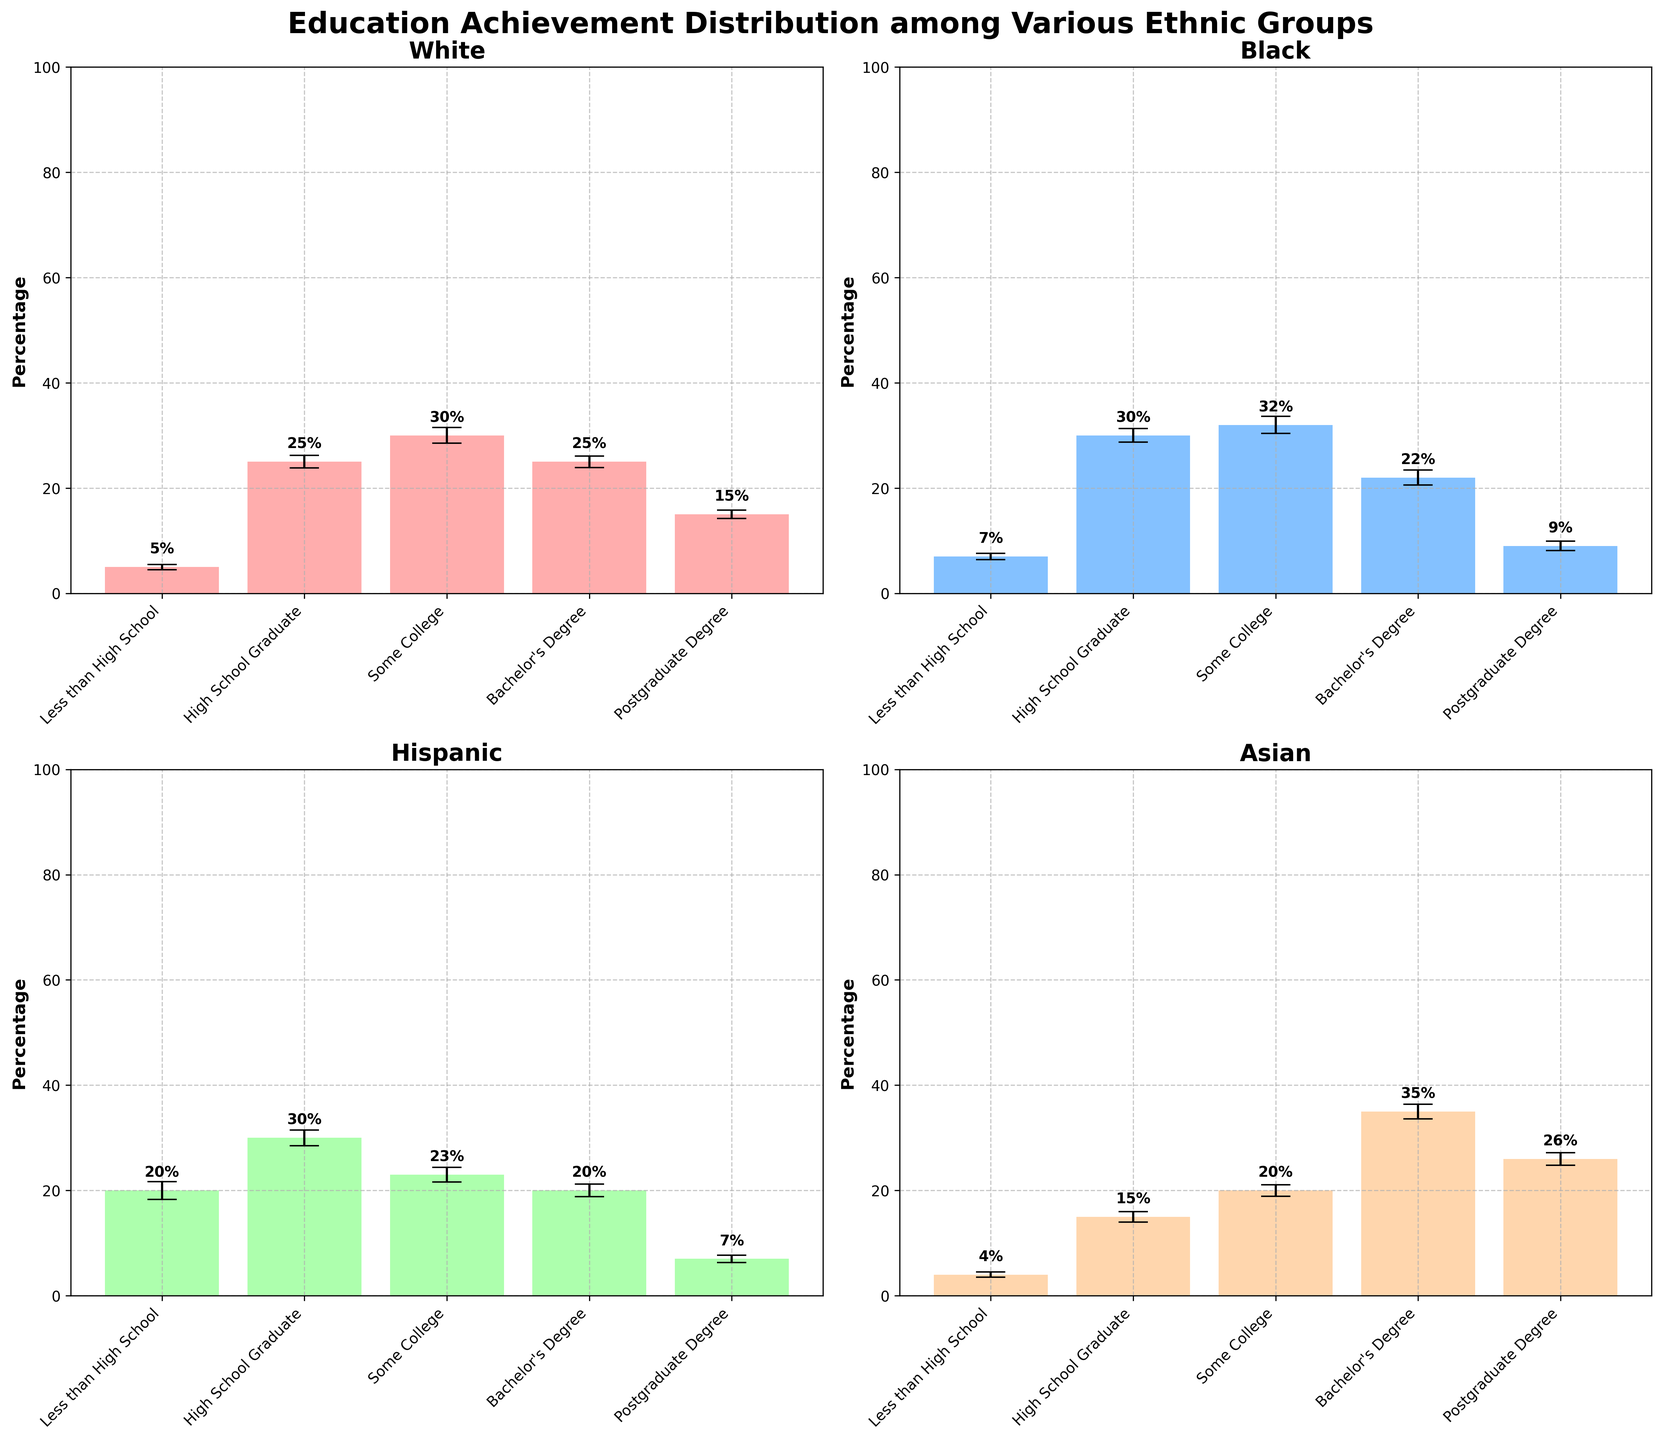What is the title of the figure? The figure's main title is displayed at the top and provides an overall description of the figure's theme. It reads "Education Achievement Distribution among Various Ethnic Groups".
Answer: Education Achievement Distribution among Various Ethnic Groups Which ethnic group has the highest percentage of individuals with a Bachelor's Degree? By examining the individual bars labeled "Bachelor's Degree" for each ethnic group, we can see that the Asian group has the highest percentage bar.
Answer: Asian What is the percentage of Hispanic individuals with less than a high school education? Find the subplot for Hispanic individuals, and identify the bar labeled "Less than High School". The top of this bar represents the percentage.
Answer: 20% How does the percentage of Black individuals with a postgraduate degree compare to that of Hispanic individuals? By observing the "Postgraduate Degree" bars in the Black and Hispanic subplots, the percentage is higher for the Black group (9%) compared to the Hispanic group (7%).
Answer: Higher for Black (9% vs 7%) What is the margin of error for the percentage of White individuals with some college education? In the subplot for White individuals, find the error bar associated with the "Some College" bar. The length of this error bar is the margin of error.
Answer: 1.5 Which ethnic group shows the lowest percentage for "High School Graduate"? Look at the "High School Graduate" bars across all subplots, and see which bar is the shortest. The Asian group has the lowest percentage for this education level.
Answer: Asian For which education level do all ethnic groups have the margins of error almost equal within 0.5%? By comparing the length of the error bars for each education level across all subplots, we can see that the "Less than High School" education level has error bars of 0.5% or 0.6%, which fall into a close range.
Answer: Less than High School What's the combined percentage of Black individuals who have some college education or a high school graduate? In the Black subplot, sum the percentages of the "Some College" and "High School Graduate" bars (32% + 30%).
Answer: 62% Which group displays the highest margin of error on a single data point, and what is that value? By inspecting the error bars across all subplots, the Hispanic group's "Less than High School" category has the longest error bar, denoting the highest margin of error at 1.7%.
Answer: Hispanic, 1.7 Are there any ethnic groups where two different education levels have the same percentage? If so, which group and education levels? Checking the height of bars within each subplot, we observe the White group has 25% for both "High School Graduate" and "Bachelor's Degree".
Answer: White, High School Graduate and Bachelor's Degree 